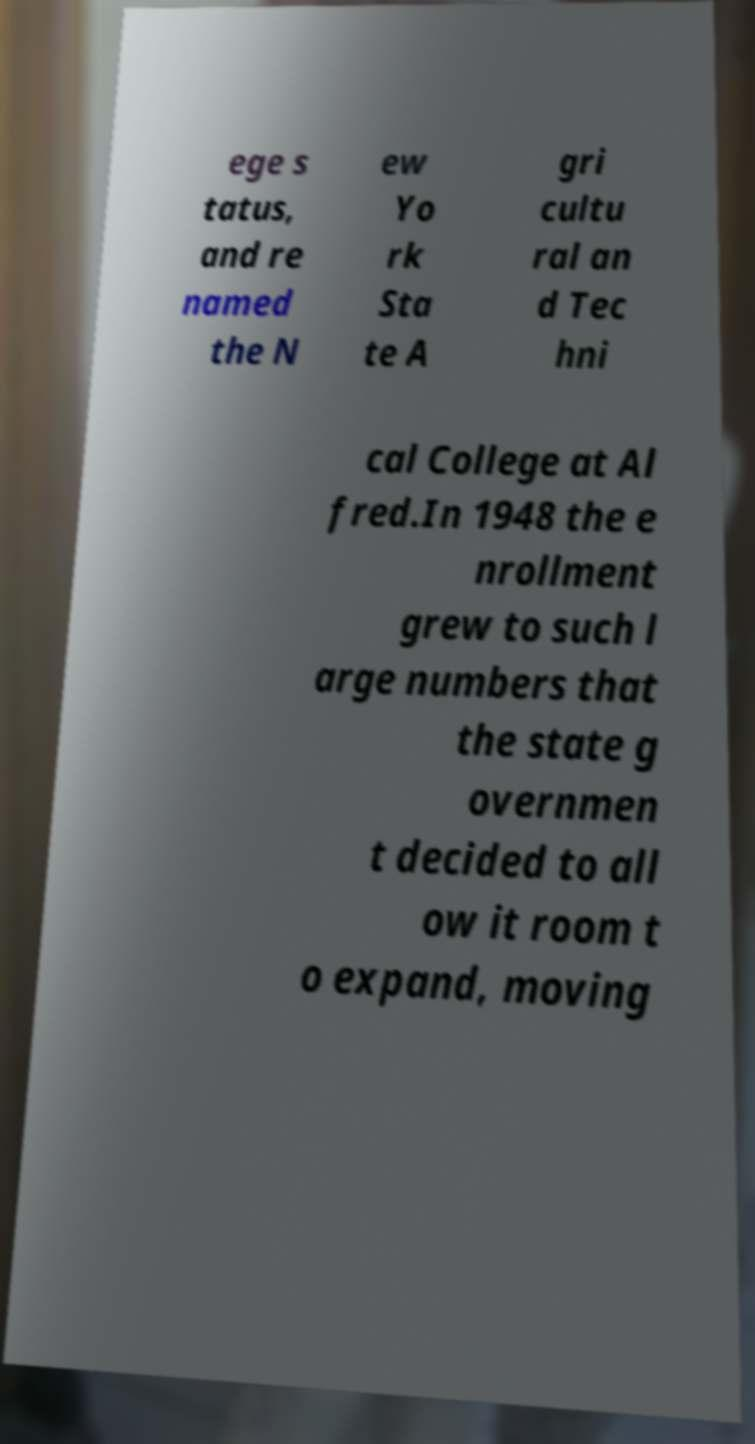Please read and relay the text visible in this image. What does it say? ege s tatus, and re named the N ew Yo rk Sta te A gri cultu ral an d Tec hni cal College at Al fred.In 1948 the e nrollment grew to such l arge numbers that the state g overnmen t decided to all ow it room t o expand, moving 